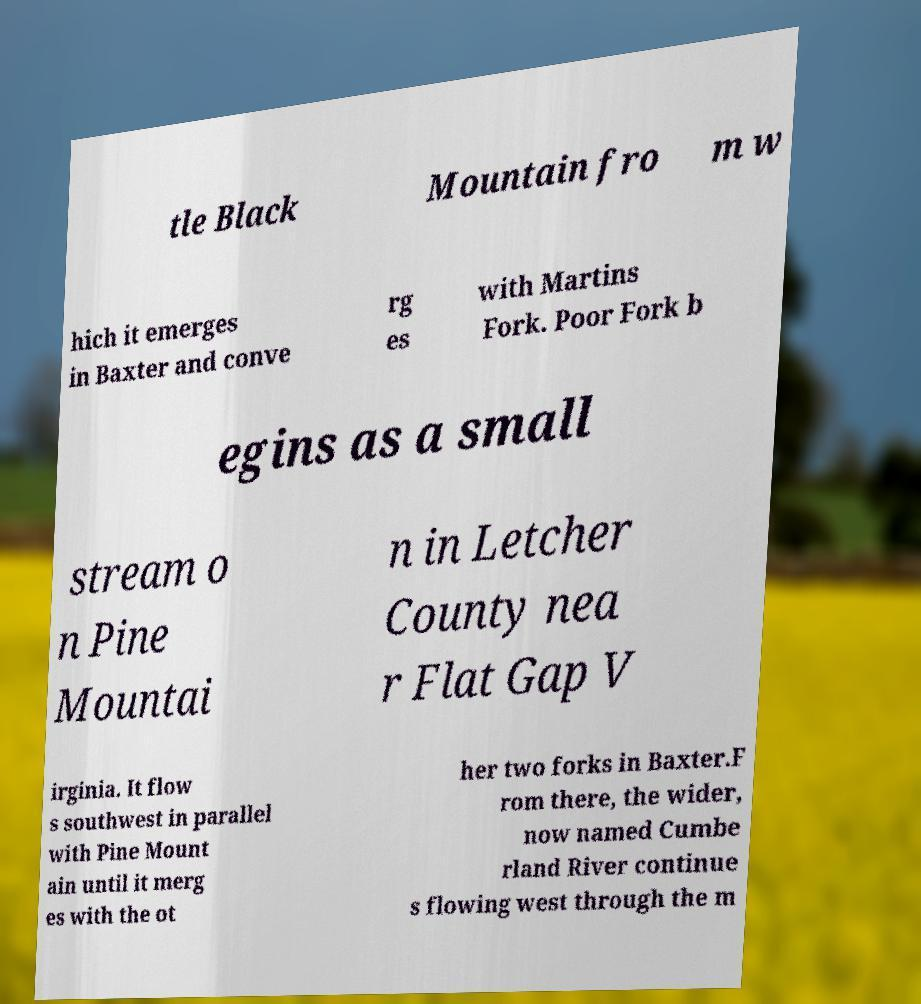For documentation purposes, I need the text within this image transcribed. Could you provide that? tle Black Mountain fro m w hich it emerges in Baxter and conve rg es with Martins Fork. Poor Fork b egins as a small stream o n Pine Mountai n in Letcher County nea r Flat Gap V irginia. It flow s southwest in parallel with Pine Mount ain until it merg es with the ot her two forks in Baxter.F rom there, the wider, now named Cumbe rland River continue s flowing west through the m 